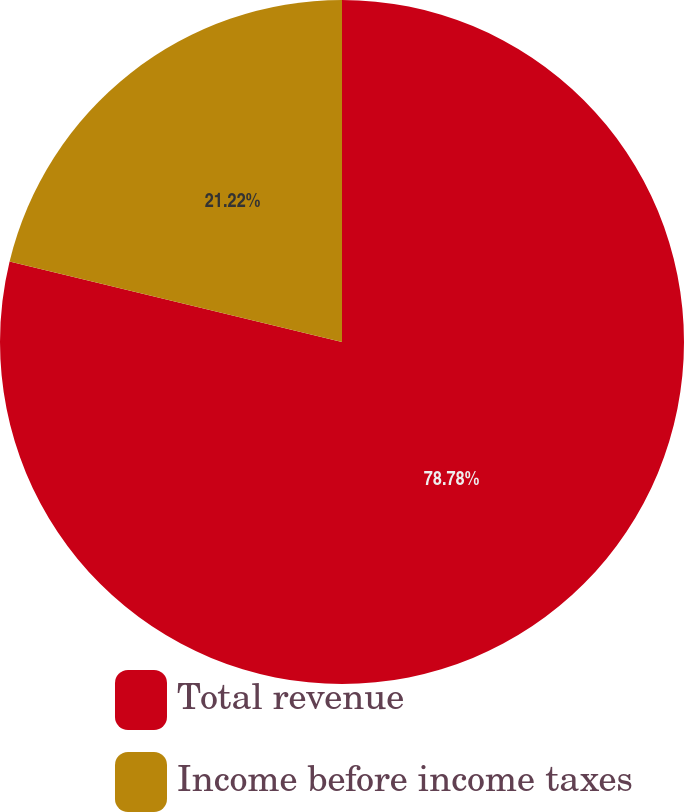<chart> <loc_0><loc_0><loc_500><loc_500><pie_chart><fcel>Total revenue<fcel>Income before income taxes<nl><fcel>78.78%<fcel>21.22%<nl></chart> 